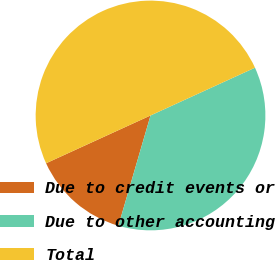<chart> <loc_0><loc_0><loc_500><loc_500><pie_chart><fcel>Due to credit events or<fcel>Due to other accounting<fcel>Total<nl><fcel>13.66%<fcel>36.34%<fcel>50.0%<nl></chart> 